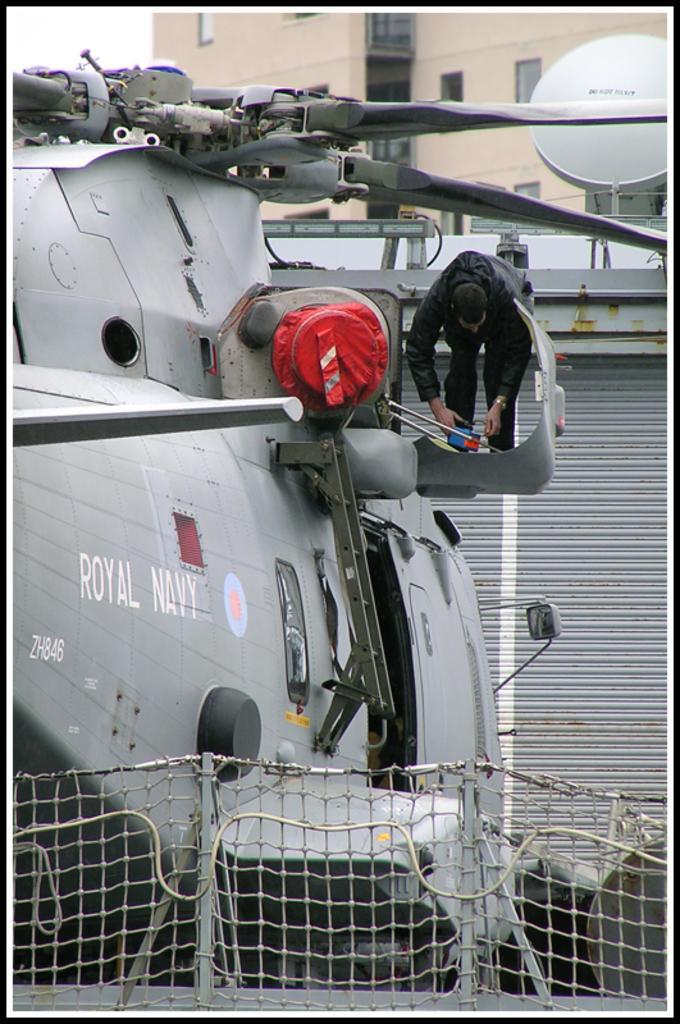Please provide a concise description of this image. In this image there is a man who is wearing black dress and doing some work. He is standing on the helicopter. On the bottom there is a net. On the left there is a shelter near to the chopper. At the top we can see the building. At the top left corner there is a sky. 